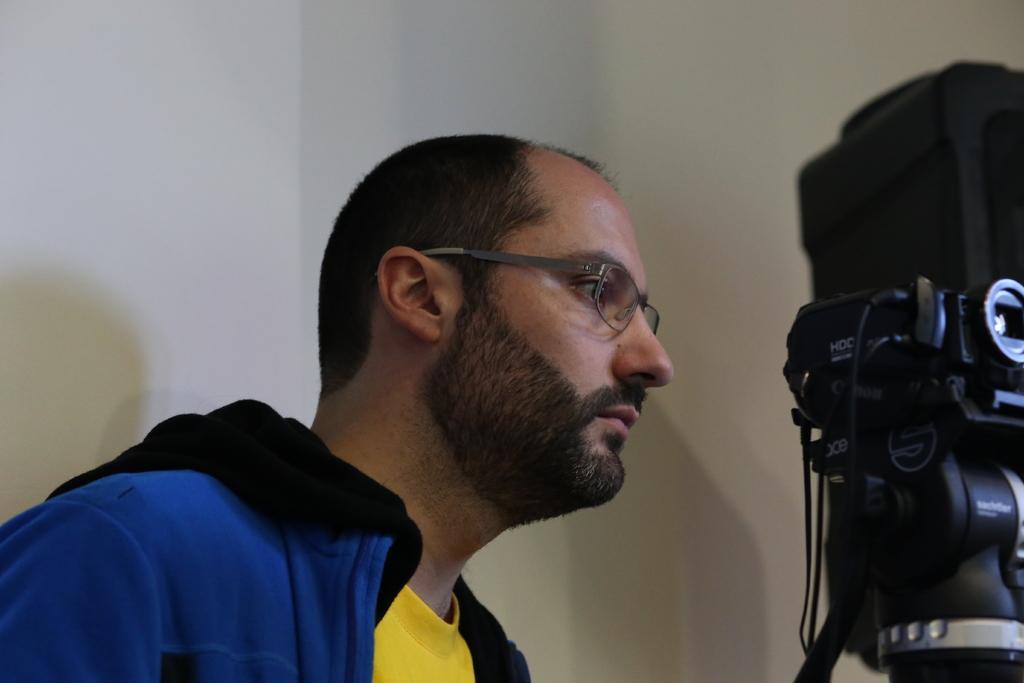Can you describe this image briefly? In this image, we can see a man standing and he is wearing specs, he is wearing a blue color jacket, at the right side there is a black color camera, in the background there is a white color wall. 